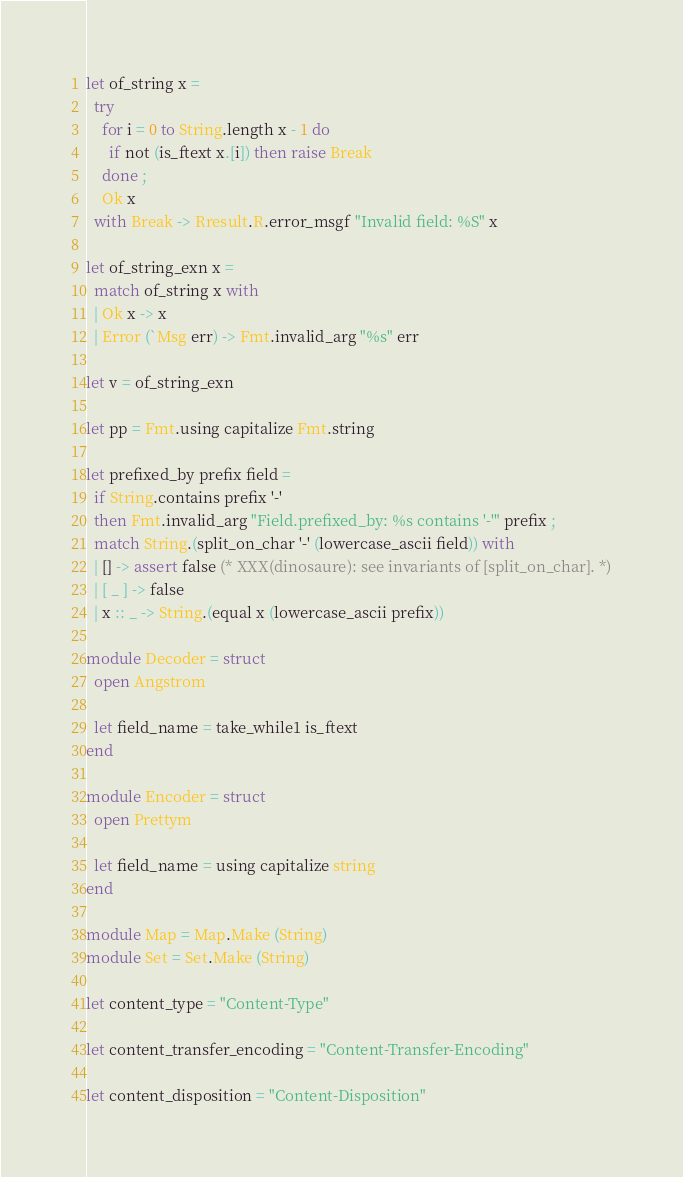Convert code to text. <code><loc_0><loc_0><loc_500><loc_500><_OCaml_>
let of_string x =
  try
    for i = 0 to String.length x - 1 do
      if not (is_ftext x.[i]) then raise Break
    done ;
    Ok x
  with Break -> Rresult.R.error_msgf "Invalid field: %S" x

let of_string_exn x =
  match of_string x with
  | Ok x -> x
  | Error (`Msg err) -> Fmt.invalid_arg "%s" err

let v = of_string_exn

let pp = Fmt.using capitalize Fmt.string

let prefixed_by prefix field =
  if String.contains prefix '-'
  then Fmt.invalid_arg "Field.prefixed_by: %s contains '-'" prefix ;
  match String.(split_on_char '-' (lowercase_ascii field)) with
  | [] -> assert false (* XXX(dinosaure): see invariants of [split_on_char]. *)
  | [ _ ] -> false
  | x :: _ -> String.(equal x (lowercase_ascii prefix))

module Decoder = struct
  open Angstrom

  let field_name = take_while1 is_ftext
end

module Encoder = struct
  open Prettym

  let field_name = using capitalize string
end

module Map = Map.Make (String)
module Set = Set.Make (String)

let content_type = "Content-Type"

let content_transfer_encoding = "Content-Transfer-Encoding"

let content_disposition = "Content-Disposition"
</code> 